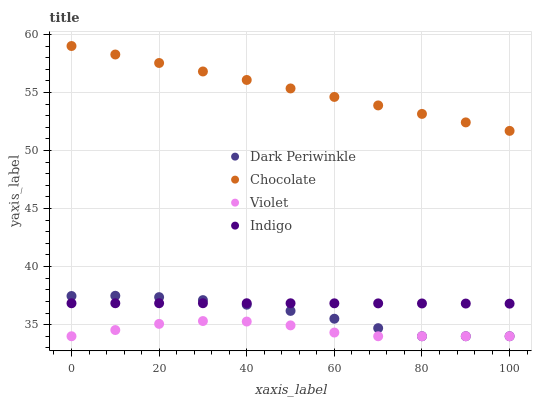Does Violet have the minimum area under the curve?
Answer yes or no. Yes. Does Chocolate have the maximum area under the curve?
Answer yes or no. Yes. Does Indigo have the minimum area under the curve?
Answer yes or no. No. Does Indigo have the maximum area under the curve?
Answer yes or no. No. Is Chocolate the smoothest?
Answer yes or no. Yes. Is Violet the roughest?
Answer yes or no. Yes. Is Indigo the smoothest?
Answer yes or no. No. Is Indigo the roughest?
Answer yes or no. No. Does Violet have the lowest value?
Answer yes or no. Yes. Does Indigo have the lowest value?
Answer yes or no. No. Does Chocolate have the highest value?
Answer yes or no. Yes. Does Indigo have the highest value?
Answer yes or no. No. Is Dark Periwinkle less than Chocolate?
Answer yes or no. Yes. Is Chocolate greater than Indigo?
Answer yes or no. Yes. Does Indigo intersect Dark Periwinkle?
Answer yes or no. Yes. Is Indigo less than Dark Periwinkle?
Answer yes or no. No. Is Indigo greater than Dark Periwinkle?
Answer yes or no. No. Does Dark Periwinkle intersect Chocolate?
Answer yes or no. No. 